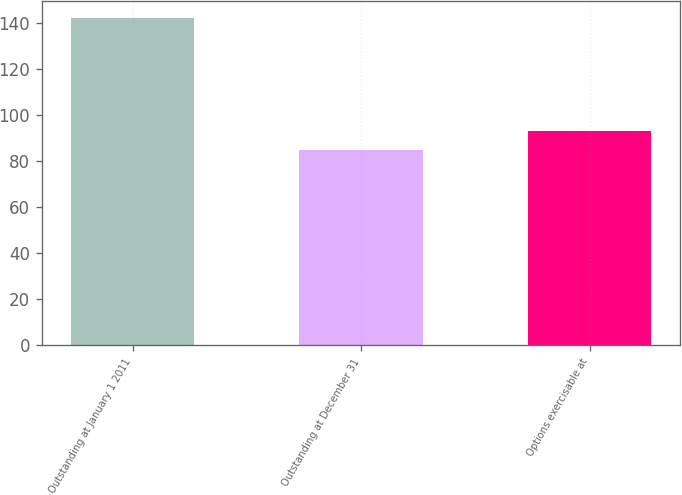Convert chart to OTSL. <chart><loc_0><loc_0><loc_500><loc_500><bar_chart><fcel>Outstanding at January 1 2011<fcel>Outstanding at December 31<fcel>Options exercisable at<nl><fcel>142.2<fcel>84.64<fcel>92.98<nl></chart> 